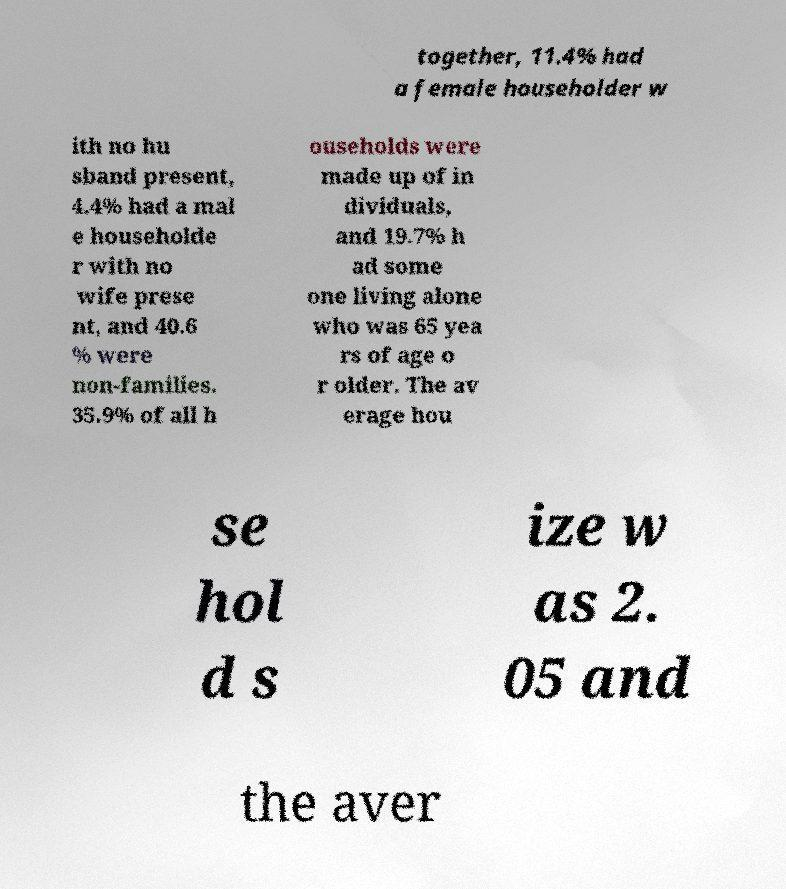Please read and relay the text visible in this image. What does it say? together, 11.4% had a female householder w ith no hu sband present, 4.4% had a mal e householde r with no wife prese nt, and 40.6 % were non-families. 35.9% of all h ouseholds were made up of in dividuals, and 19.7% h ad some one living alone who was 65 yea rs of age o r older. The av erage hou se hol d s ize w as 2. 05 and the aver 